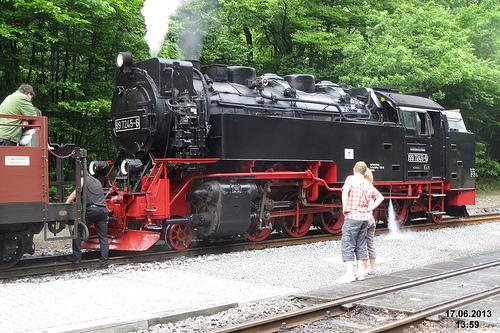Question: how many people are in the picture?
Choices:
A. 4.
B. 3.
C. 2.
D. 1.
Answer with the letter. Answer: A Question: where are the people?
Choices:
A. Stadium.
B. Railroad.
C. Home.
D. Bus stop.
Answer with the letter. Answer: B Question: who is in the photo?
Choices:
A. Nobody.
B. Wolves.
C. Cows.
D. People.
Answer with the letter. Answer: D Question: what is in the photograph?
Choices:
A. A train.
B. A trolley.
C. A bus.
D. A truck.
Answer with the letter. Answer: A 